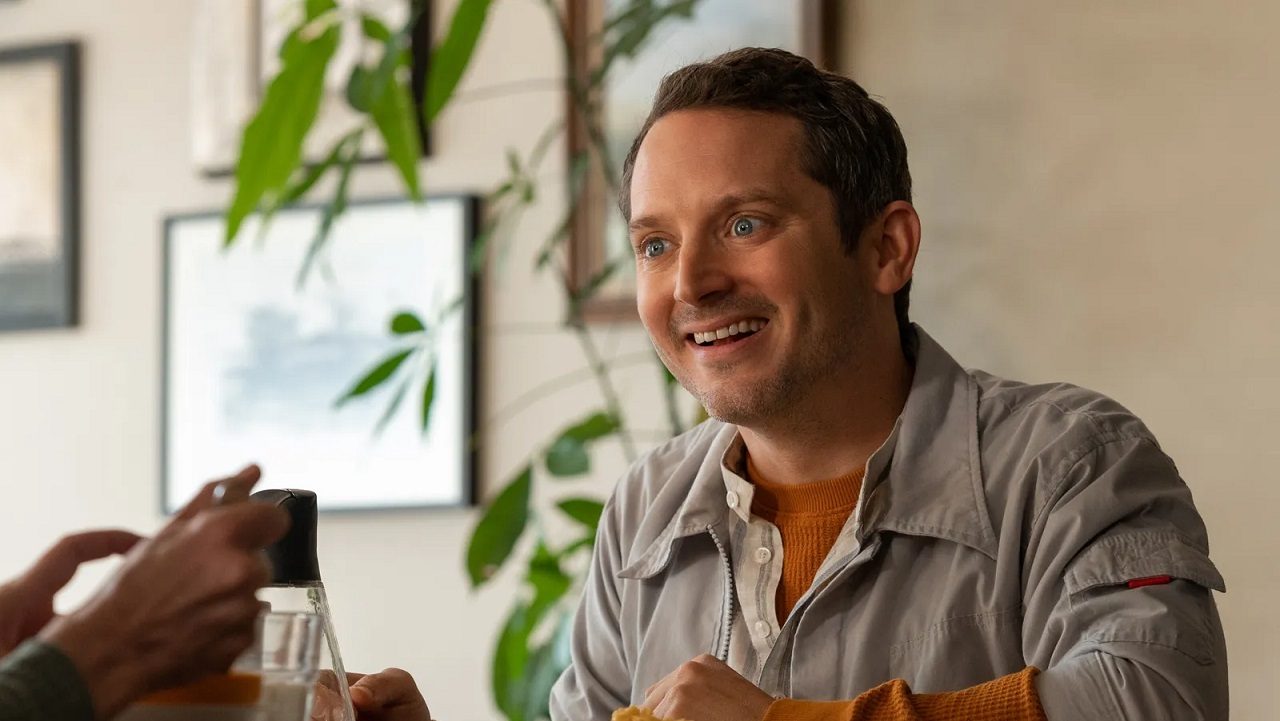Write a detailed description of the given image. In this image, there is a happy and engaging man seated at a table in what appears to be a restaurant or casual dining setting. He is smiling warmly and looking at someone off-camera, suggesting he is involved in an enjoyable conversation. The man is dressed in a gray jacket over a mustard yellow sweater, giving him a relaxed yet stylish appearance. His hands are positioned near a glass of what could be beer or another beverage, indicating he might be partaking in a moment of leisure or celebration. The background features greenery, with several plants adding a fresh and natural touch to the indoor space. Additionally, there are framed pictures on the walls and a glimpse of a building is visible through the window, placing the scene in an urban context. The overall atmosphere of the image is warm and inviting, capturing a moment of joy and social interaction. 